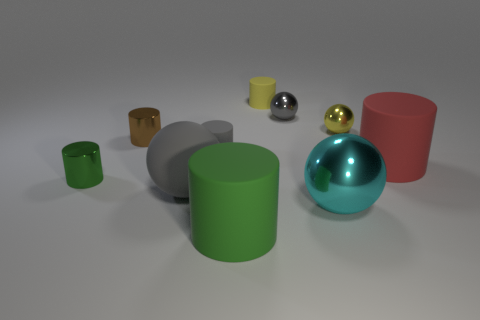There is a green matte object that is the same shape as the tiny green shiny object; what is its size?
Your answer should be compact. Large. What number of tiny gray things have the same material as the small green thing?
Provide a succinct answer. 1. What number of other big metal things are the same color as the large shiny thing?
Provide a short and direct response. 0. What number of objects are large things to the right of the gray matte sphere or small green shiny objects in front of the brown thing?
Make the answer very short. 4. Is the number of big rubber spheres right of the small yellow cylinder less than the number of large rubber balls?
Provide a succinct answer. Yes. Are there any gray things of the same size as the brown shiny object?
Your response must be concise. Yes. The large rubber sphere has what color?
Keep it short and to the point. Gray. Do the yellow rubber thing and the yellow shiny ball have the same size?
Your response must be concise. Yes. What number of things are metallic spheres or red rubber objects?
Offer a very short reply. 4. Are there the same number of brown metal cylinders that are in front of the brown metallic cylinder and small green shiny objects?
Ensure brevity in your answer.  No. 